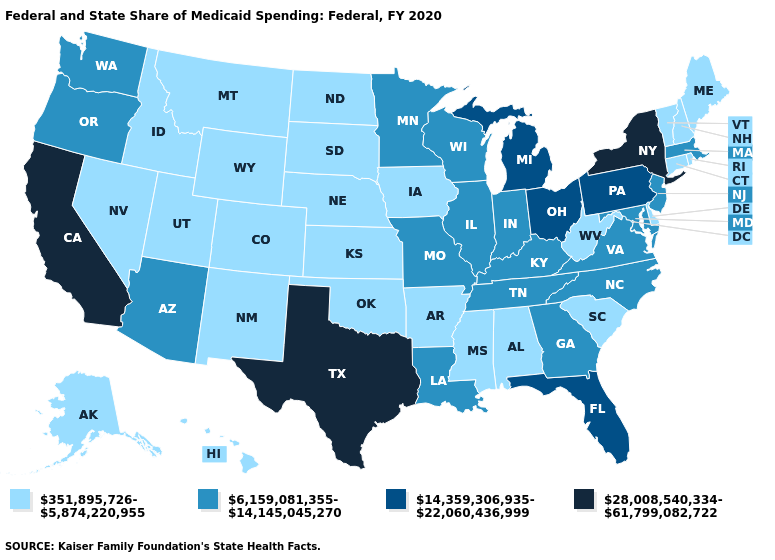Name the states that have a value in the range 28,008,540,334-61,799,082,722?
Keep it brief. California, New York, Texas. Name the states that have a value in the range 28,008,540,334-61,799,082,722?
Write a very short answer. California, New York, Texas. Does Illinois have a lower value than New York?
Write a very short answer. Yes. Does the first symbol in the legend represent the smallest category?
Write a very short answer. Yes. Among the states that border Arkansas , which have the lowest value?
Quick response, please. Mississippi, Oklahoma. Does the first symbol in the legend represent the smallest category?
Quick response, please. Yes. What is the lowest value in the West?
Be succinct. 351,895,726-5,874,220,955. Does the first symbol in the legend represent the smallest category?
Answer briefly. Yes. Does California have the lowest value in the West?
Write a very short answer. No. Which states have the highest value in the USA?
Short answer required. California, New York, Texas. Does the first symbol in the legend represent the smallest category?
Keep it brief. Yes. What is the value of Nebraska?
Give a very brief answer. 351,895,726-5,874,220,955. Which states hav the highest value in the MidWest?
Short answer required. Michigan, Ohio. 